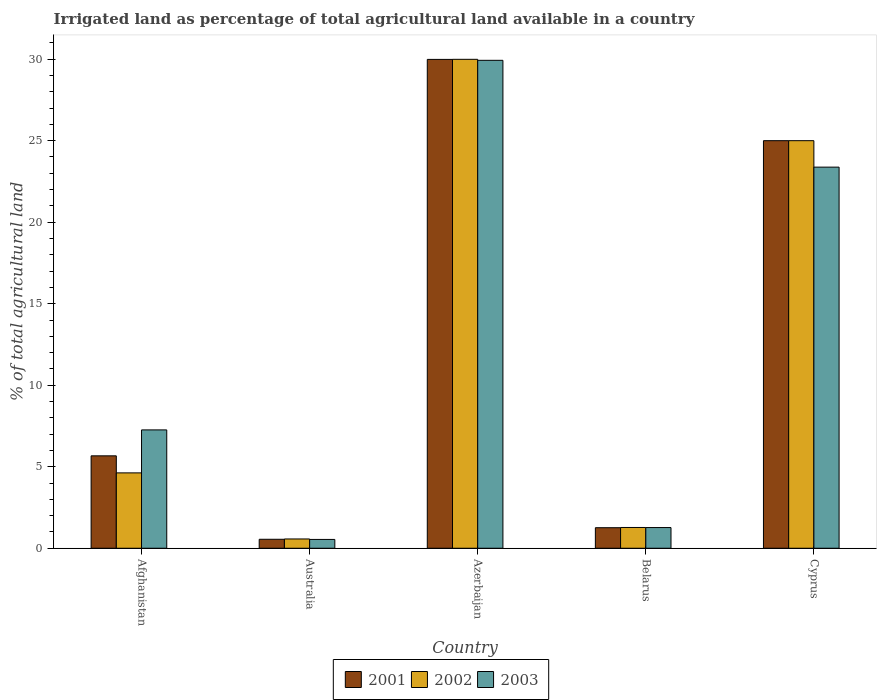How many groups of bars are there?
Offer a very short reply. 5. Are the number of bars per tick equal to the number of legend labels?
Make the answer very short. Yes. What is the label of the 4th group of bars from the left?
Your answer should be very brief. Belarus. In how many cases, is the number of bars for a given country not equal to the number of legend labels?
Offer a very short reply. 0. What is the percentage of irrigated land in 2001 in Australia?
Offer a terse response. 0.55. Across all countries, what is the maximum percentage of irrigated land in 2001?
Provide a short and direct response. 29.99. Across all countries, what is the minimum percentage of irrigated land in 2003?
Keep it short and to the point. 0.54. In which country was the percentage of irrigated land in 2001 maximum?
Your answer should be very brief. Azerbaijan. What is the total percentage of irrigated land in 2002 in the graph?
Offer a terse response. 61.46. What is the difference between the percentage of irrigated land in 2001 in Azerbaijan and that in Belarus?
Your response must be concise. 28.73. What is the difference between the percentage of irrigated land in 2003 in Afghanistan and the percentage of irrigated land in 2002 in Belarus?
Make the answer very short. 5.99. What is the average percentage of irrigated land in 2002 per country?
Offer a very short reply. 12.29. What is the difference between the percentage of irrigated land of/in 2002 and percentage of irrigated land of/in 2001 in Belarus?
Provide a succinct answer. 0.01. In how many countries, is the percentage of irrigated land in 2002 greater than 1 %?
Offer a terse response. 4. What is the ratio of the percentage of irrigated land in 2002 in Afghanistan to that in Belarus?
Your answer should be compact. 3.63. Is the difference between the percentage of irrigated land in 2002 in Belarus and Cyprus greater than the difference between the percentage of irrigated land in 2001 in Belarus and Cyprus?
Your answer should be compact. Yes. What is the difference between the highest and the second highest percentage of irrigated land in 2001?
Give a very brief answer. 19.33. What is the difference between the highest and the lowest percentage of irrigated land in 2003?
Ensure brevity in your answer.  29.39. In how many countries, is the percentage of irrigated land in 2003 greater than the average percentage of irrigated land in 2003 taken over all countries?
Your answer should be compact. 2. Is the sum of the percentage of irrigated land in 2003 in Belarus and Cyprus greater than the maximum percentage of irrigated land in 2002 across all countries?
Offer a terse response. No. Are all the bars in the graph horizontal?
Keep it short and to the point. No. What is the difference between two consecutive major ticks on the Y-axis?
Provide a short and direct response. 5. Does the graph contain any zero values?
Provide a short and direct response. No. Where does the legend appear in the graph?
Your answer should be compact. Bottom center. How many legend labels are there?
Offer a very short reply. 3. How are the legend labels stacked?
Your response must be concise. Horizontal. What is the title of the graph?
Keep it short and to the point. Irrigated land as percentage of total agricultural land available in a country. What is the label or title of the X-axis?
Provide a short and direct response. Country. What is the label or title of the Y-axis?
Your answer should be very brief. % of total agricultural land. What is the % of total agricultural land in 2001 in Afghanistan?
Your answer should be compact. 5.67. What is the % of total agricultural land in 2002 in Afghanistan?
Offer a very short reply. 4.62. What is the % of total agricultural land of 2003 in Afghanistan?
Provide a short and direct response. 7.26. What is the % of total agricultural land of 2001 in Australia?
Provide a succinct answer. 0.55. What is the % of total agricultural land of 2002 in Australia?
Offer a very short reply. 0.57. What is the % of total agricultural land of 2003 in Australia?
Your answer should be compact. 0.54. What is the % of total agricultural land of 2001 in Azerbaijan?
Ensure brevity in your answer.  29.99. What is the % of total agricultural land in 2002 in Azerbaijan?
Offer a very short reply. 29.99. What is the % of total agricultural land of 2003 in Azerbaijan?
Give a very brief answer. 29.93. What is the % of total agricultural land of 2001 in Belarus?
Give a very brief answer. 1.26. What is the % of total agricultural land of 2002 in Belarus?
Provide a short and direct response. 1.27. What is the % of total agricultural land in 2003 in Belarus?
Provide a succinct answer. 1.27. What is the % of total agricultural land of 2001 in Cyprus?
Give a very brief answer. 25. What is the % of total agricultural land of 2003 in Cyprus?
Offer a very short reply. 23.38. Across all countries, what is the maximum % of total agricultural land of 2001?
Your answer should be compact. 29.99. Across all countries, what is the maximum % of total agricultural land of 2002?
Offer a very short reply. 29.99. Across all countries, what is the maximum % of total agricultural land of 2003?
Offer a terse response. 29.93. Across all countries, what is the minimum % of total agricultural land in 2001?
Offer a terse response. 0.55. Across all countries, what is the minimum % of total agricultural land in 2002?
Make the answer very short. 0.57. Across all countries, what is the minimum % of total agricultural land of 2003?
Your answer should be compact. 0.54. What is the total % of total agricultural land of 2001 in the graph?
Provide a short and direct response. 62.46. What is the total % of total agricultural land in 2002 in the graph?
Offer a very short reply. 61.46. What is the total % of total agricultural land in 2003 in the graph?
Provide a short and direct response. 62.37. What is the difference between the % of total agricultural land of 2001 in Afghanistan and that in Australia?
Offer a terse response. 5.12. What is the difference between the % of total agricultural land in 2002 in Afghanistan and that in Australia?
Ensure brevity in your answer.  4.05. What is the difference between the % of total agricultural land of 2003 in Afghanistan and that in Australia?
Provide a succinct answer. 6.72. What is the difference between the % of total agricultural land in 2001 in Afghanistan and that in Azerbaijan?
Ensure brevity in your answer.  -24.32. What is the difference between the % of total agricultural land in 2002 in Afghanistan and that in Azerbaijan?
Keep it short and to the point. -25.37. What is the difference between the % of total agricultural land in 2003 in Afghanistan and that in Azerbaijan?
Ensure brevity in your answer.  -22.67. What is the difference between the % of total agricultural land of 2001 in Afghanistan and that in Belarus?
Offer a terse response. 4.41. What is the difference between the % of total agricultural land of 2002 in Afghanistan and that in Belarus?
Give a very brief answer. 3.35. What is the difference between the % of total agricultural land of 2003 in Afghanistan and that in Belarus?
Offer a terse response. 5.99. What is the difference between the % of total agricultural land in 2001 in Afghanistan and that in Cyprus?
Offer a very short reply. -19.33. What is the difference between the % of total agricultural land of 2002 in Afghanistan and that in Cyprus?
Offer a terse response. -20.38. What is the difference between the % of total agricultural land in 2003 in Afghanistan and that in Cyprus?
Keep it short and to the point. -16.12. What is the difference between the % of total agricultural land in 2001 in Australia and that in Azerbaijan?
Your answer should be compact. -29.44. What is the difference between the % of total agricultural land in 2002 in Australia and that in Azerbaijan?
Offer a very short reply. -29.42. What is the difference between the % of total agricultural land of 2003 in Australia and that in Azerbaijan?
Your answer should be very brief. -29.39. What is the difference between the % of total agricultural land of 2001 in Australia and that in Belarus?
Your answer should be very brief. -0.71. What is the difference between the % of total agricultural land of 2002 in Australia and that in Belarus?
Your answer should be compact. -0.7. What is the difference between the % of total agricultural land of 2003 in Australia and that in Belarus?
Ensure brevity in your answer.  -0.73. What is the difference between the % of total agricultural land in 2001 in Australia and that in Cyprus?
Provide a succinct answer. -24.45. What is the difference between the % of total agricultural land of 2002 in Australia and that in Cyprus?
Keep it short and to the point. -24.43. What is the difference between the % of total agricultural land of 2003 in Australia and that in Cyprus?
Ensure brevity in your answer.  -22.84. What is the difference between the % of total agricultural land in 2001 in Azerbaijan and that in Belarus?
Your response must be concise. 28.73. What is the difference between the % of total agricultural land of 2002 in Azerbaijan and that in Belarus?
Give a very brief answer. 28.72. What is the difference between the % of total agricultural land of 2003 in Azerbaijan and that in Belarus?
Ensure brevity in your answer.  28.66. What is the difference between the % of total agricultural land in 2001 in Azerbaijan and that in Cyprus?
Your answer should be compact. 4.99. What is the difference between the % of total agricultural land in 2002 in Azerbaijan and that in Cyprus?
Provide a succinct answer. 4.99. What is the difference between the % of total agricultural land of 2003 in Azerbaijan and that in Cyprus?
Keep it short and to the point. 6.55. What is the difference between the % of total agricultural land in 2001 in Belarus and that in Cyprus?
Offer a very short reply. -23.74. What is the difference between the % of total agricultural land in 2002 in Belarus and that in Cyprus?
Your response must be concise. -23.73. What is the difference between the % of total agricultural land in 2003 in Belarus and that in Cyprus?
Ensure brevity in your answer.  -22.11. What is the difference between the % of total agricultural land in 2001 in Afghanistan and the % of total agricultural land in 2002 in Australia?
Give a very brief answer. 5.1. What is the difference between the % of total agricultural land in 2001 in Afghanistan and the % of total agricultural land in 2003 in Australia?
Give a very brief answer. 5.13. What is the difference between the % of total agricultural land in 2002 in Afghanistan and the % of total agricultural land in 2003 in Australia?
Your answer should be very brief. 4.08. What is the difference between the % of total agricultural land of 2001 in Afghanistan and the % of total agricultural land of 2002 in Azerbaijan?
Offer a very short reply. -24.32. What is the difference between the % of total agricultural land in 2001 in Afghanistan and the % of total agricultural land in 2003 in Azerbaijan?
Ensure brevity in your answer.  -24.26. What is the difference between the % of total agricultural land of 2002 in Afghanistan and the % of total agricultural land of 2003 in Azerbaijan?
Provide a short and direct response. -25.31. What is the difference between the % of total agricultural land of 2001 in Afghanistan and the % of total agricultural land of 2002 in Belarus?
Your answer should be very brief. 4.39. What is the difference between the % of total agricultural land in 2001 in Afghanistan and the % of total agricultural land in 2003 in Belarus?
Offer a very short reply. 4.4. What is the difference between the % of total agricultural land in 2002 in Afghanistan and the % of total agricultural land in 2003 in Belarus?
Provide a short and direct response. 3.35. What is the difference between the % of total agricultural land of 2001 in Afghanistan and the % of total agricultural land of 2002 in Cyprus?
Your answer should be very brief. -19.33. What is the difference between the % of total agricultural land of 2001 in Afghanistan and the % of total agricultural land of 2003 in Cyprus?
Ensure brevity in your answer.  -17.71. What is the difference between the % of total agricultural land in 2002 in Afghanistan and the % of total agricultural land in 2003 in Cyprus?
Your answer should be very brief. -18.75. What is the difference between the % of total agricultural land of 2001 in Australia and the % of total agricultural land of 2002 in Azerbaijan?
Your response must be concise. -29.44. What is the difference between the % of total agricultural land in 2001 in Australia and the % of total agricultural land in 2003 in Azerbaijan?
Keep it short and to the point. -29.38. What is the difference between the % of total agricultural land of 2002 in Australia and the % of total agricultural land of 2003 in Azerbaijan?
Keep it short and to the point. -29.36. What is the difference between the % of total agricultural land in 2001 in Australia and the % of total agricultural land in 2002 in Belarus?
Your response must be concise. -0.72. What is the difference between the % of total agricultural land in 2001 in Australia and the % of total agricultural land in 2003 in Belarus?
Provide a succinct answer. -0.72. What is the difference between the % of total agricultural land in 2002 in Australia and the % of total agricultural land in 2003 in Belarus?
Your answer should be compact. -0.7. What is the difference between the % of total agricultural land of 2001 in Australia and the % of total agricultural land of 2002 in Cyprus?
Keep it short and to the point. -24.45. What is the difference between the % of total agricultural land of 2001 in Australia and the % of total agricultural land of 2003 in Cyprus?
Your response must be concise. -22.83. What is the difference between the % of total agricultural land of 2002 in Australia and the % of total agricultural land of 2003 in Cyprus?
Ensure brevity in your answer.  -22.81. What is the difference between the % of total agricultural land of 2001 in Azerbaijan and the % of total agricultural land of 2002 in Belarus?
Give a very brief answer. 28.71. What is the difference between the % of total agricultural land in 2001 in Azerbaijan and the % of total agricultural land in 2003 in Belarus?
Your response must be concise. 28.72. What is the difference between the % of total agricultural land of 2002 in Azerbaijan and the % of total agricultural land of 2003 in Belarus?
Your response must be concise. 28.72. What is the difference between the % of total agricultural land of 2001 in Azerbaijan and the % of total agricultural land of 2002 in Cyprus?
Make the answer very short. 4.99. What is the difference between the % of total agricultural land of 2001 in Azerbaijan and the % of total agricultural land of 2003 in Cyprus?
Keep it short and to the point. 6.61. What is the difference between the % of total agricultural land of 2002 in Azerbaijan and the % of total agricultural land of 2003 in Cyprus?
Ensure brevity in your answer.  6.61. What is the difference between the % of total agricultural land of 2001 in Belarus and the % of total agricultural land of 2002 in Cyprus?
Provide a succinct answer. -23.74. What is the difference between the % of total agricultural land of 2001 in Belarus and the % of total agricultural land of 2003 in Cyprus?
Provide a succinct answer. -22.12. What is the difference between the % of total agricultural land in 2002 in Belarus and the % of total agricultural land in 2003 in Cyprus?
Give a very brief answer. -22.1. What is the average % of total agricultural land in 2001 per country?
Offer a very short reply. 12.49. What is the average % of total agricultural land of 2002 per country?
Ensure brevity in your answer.  12.29. What is the average % of total agricultural land in 2003 per country?
Provide a short and direct response. 12.47. What is the difference between the % of total agricultural land of 2001 and % of total agricultural land of 2002 in Afghanistan?
Offer a very short reply. 1.05. What is the difference between the % of total agricultural land of 2001 and % of total agricultural land of 2003 in Afghanistan?
Ensure brevity in your answer.  -1.59. What is the difference between the % of total agricultural land in 2002 and % of total agricultural land in 2003 in Afghanistan?
Give a very brief answer. -2.64. What is the difference between the % of total agricultural land of 2001 and % of total agricultural land of 2002 in Australia?
Your response must be concise. -0.02. What is the difference between the % of total agricultural land in 2001 and % of total agricultural land in 2003 in Australia?
Keep it short and to the point. 0.01. What is the difference between the % of total agricultural land in 2002 and % of total agricultural land in 2003 in Australia?
Provide a short and direct response. 0.03. What is the difference between the % of total agricultural land in 2001 and % of total agricultural land in 2002 in Azerbaijan?
Provide a short and direct response. -0. What is the difference between the % of total agricultural land in 2001 and % of total agricultural land in 2003 in Azerbaijan?
Your response must be concise. 0.06. What is the difference between the % of total agricultural land of 2002 and % of total agricultural land of 2003 in Azerbaijan?
Keep it short and to the point. 0.06. What is the difference between the % of total agricultural land of 2001 and % of total agricultural land of 2002 in Belarus?
Your answer should be compact. -0.01. What is the difference between the % of total agricultural land of 2001 and % of total agricultural land of 2003 in Belarus?
Your response must be concise. -0.01. What is the difference between the % of total agricultural land of 2002 and % of total agricultural land of 2003 in Belarus?
Provide a succinct answer. 0.01. What is the difference between the % of total agricultural land of 2001 and % of total agricultural land of 2003 in Cyprus?
Make the answer very short. 1.62. What is the difference between the % of total agricultural land of 2002 and % of total agricultural land of 2003 in Cyprus?
Make the answer very short. 1.62. What is the ratio of the % of total agricultural land in 2001 in Afghanistan to that in Australia?
Keep it short and to the point. 10.31. What is the ratio of the % of total agricultural land of 2002 in Afghanistan to that in Australia?
Make the answer very short. 8.12. What is the ratio of the % of total agricultural land in 2003 in Afghanistan to that in Australia?
Provide a succinct answer. 13.42. What is the ratio of the % of total agricultural land in 2001 in Afghanistan to that in Azerbaijan?
Ensure brevity in your answer.  0.19. What is the ratio of the % of total agricultural land of 2002 in Afghanistan to that in Azerbaijan?
Provide a short and direct response. 0.15. What is the ratio of the % of total agricultural land of 2003 in Afghanistan to that in Azerbaijan?
Make the answer very short. 0.24. What is the ratio of the % of total agricultural land in 2001 in Afghanistan to that in Belarus?
Offer a very short reply. 4.5. What is the ratio of the % of total agricultural land of 2002 in Afghanistan to that in Belarus?
Offer a very short reply. 3.63. What is the ratio of the % of total agricultural land in 2003 in Afghanistan to that in Belarus?
Your answer should be very brief. 5.72. What is the ratio of the % of total agricultural land of 2001 in Afghanistan to that in Cyprus?
Give a very brief answer. 0.23. What is the ratio of the % of total agricultural land in 2002 in Afghanistan to that in Cyprus?
Offer a terse response. 0.18. What is the ratio of the % of total agricultural land in 2003 in Afghanistan to that in Cyprus?
Provide a succinct answer. 0.31. What is the ratio of the % of total agricultural land of 2001 in Australia to that in Azerbaijan?
Your response must be concise. 0.02. What is the ratio of the % of total agricultural land in 2002 in Australia to that in Azerbaijan?
Provide a succinct answer. 0.02. What is the ratio of the % of total agricultural land in 2003 in Australia to that in Azerbaijan?
Provide a short and direct response. 0.02. What is the ratio of the % of total agricultural land of 2001 in Australia to that in Belarus?
Give a very brief answer. 0.44. What is the ratio of the % of total agricultural land in 2002 in Australia to that in Belarus?
Provide a short and direct response. 0.45. What is the ratio of the % of total agricultural land of 2003 in Australia to that in Belarus?
Offer a terse response. 0.43. What is the ratio of the % of total agricultural land of 2001 in Australia to that in Cyprus?
Offer a terse response. 0.02. What is the ratio of the % of total agricultural land in 2002 in Australia to that in Cyprus?
Ensure brevity in your answer.  0.02. What is the ratio of the % of total agricultural land of 2003 in Australia to that in Cyprus?
Your answer should be very brief. 0.02. What is the ratio of the % of total agricultural land of 2001 in Azerbaijan to that in Belarus?
Your answer should be very brief. 23.8. What is the ratio of the % of total agricultural land in 2002 in Azerbaijan to that in Belarus?
Make the answer very short. 23.54. What is the ratio of the % of total agricultural land of 2003 in Azerbaijan to that in Belarus?
Offer a very short reply. 23.59. What is the ratio of the % of total agricultural land of 2001 in Azerbaijan to that in Cyprus?
Your answer should be very brief. 1.2. What is the ratio of the % of total agricultural land of 2002 in Azerbaijan to that in Cyprus?
Your response must be concise. 1.2. What is the ratio of the % of total agricultural land of 2003 in Azerbaijan to that in Cyprus?
Keep it short and to the point. 1.28. What is the ratio of the % of total agricultural land in 2001 in Belarus to that in Cyprus?
Give a very brief answer. 0.05. What is the ratio of the % of total agricultural land in 2002 in Belarus to that in Cyprus?
Offer a very short reply. 0.05. What is the ratio of the % of total agricultural land in 2003 in Belarus to that in Cyprus?
Ensure brevity in your answer.  0.05. What is the difference between the highest and the second highest % of total agricultural land of 2001?
Your response must be concise. 4.99. What is the difference between the highest and the second highest % of total agricultural land of 2002?
Your answer should be compact. 4.99. What is the difference between the highest and the second highest % of total agricultural land in 2003?
Provide a short and direct response. 6.55. What is the difference between the highest and the lowest % of total agricultural land of 2001?
Your response must be concise. 29.44. What is the difference between the highest and the lowest % of total agricultural land in 2002?
Provide a short and direct response. 29.42. What is the difference between the highest and the lowest % of total agricultural land in 2003?
Keep it short and to the point. 29.39. 